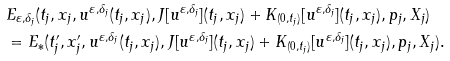Convert formula to latex. <formula><loc_0><loc_0><loc_500><loc_500>& E _ { \varepsilon , \delta _ { j } } ( t _ { j } , x _ { j } , u ^ { \varepsilon , \delta _ { j } } ( t _ { j } , x _ { j } ) , J [ u ^ { \varepsilon , \delta _ { j } } ] ( t _ { j } , x _ { j } ) + K _ { ( 0 , t _ { j } ) } [ u ^ { \varepsilon , \delta _ { j } } ] ( t _ { j } , x _ { j } ) , p _ { j } , X _ { j } ) \\ & = E _ { * } ( t ^ { \prime } _ { j } , x ^ { \prime } _ { j } , u ^ { \varepsilon , \delta _ { j } } ( t _ { j } , x _ { j } ) , J [ u ^ { \varepsilon , \delta _ { j } } ] ( t _ { j } , x _ { j } ) + K _ { ( 0 , t _ { j } ) } [ u ^ { \varepsilon , \delta _ { j } } ] ( t _ { j } , x _ { j } ) , p _ { j } , X _ { j } ) .</formula> 